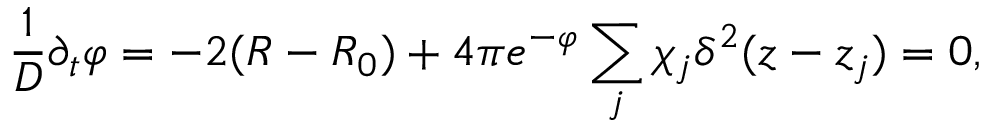<formula> <loc_0><loc_0><loc_500><loc_500>\frac { 1 } { D } \partial _ { t } \varphi = - 2 ( R - R _ { 0 } ) + 4 \pi e ^ { - \varphi } \sum _ { j } \chi _ { j } \delta ^ { 2 } ( z - z _ { j } ) = 0 ,</formula> 